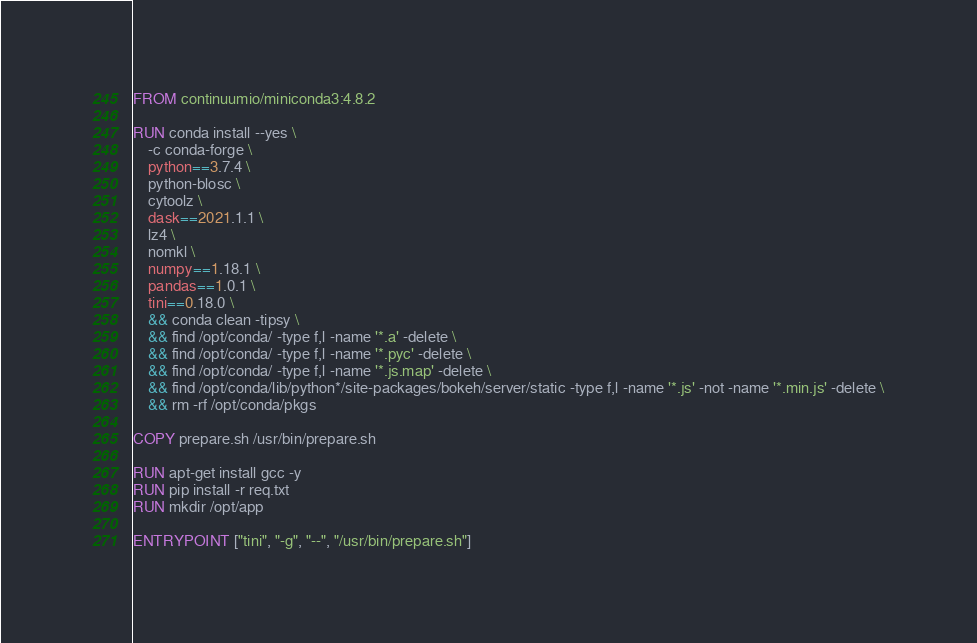Convert code to text. <code><loc_0><loc_0><loc_500><loc_500><_Dockerfile_>FROM continuumio/miniconda3:4.8.2

RUN conda install --yes \
    -c conda-forge \
    python==3.7.4 \
    python-blosc \
    cytoolz \
    dask==2021.1.1 \
    lz4 \
    nomkl \
    numpy==1.18.1 \
    pandas==1.0.1 \
    tini==0.18.0 \
    && conda clean -tipsy \
    && find /opt/conda/ -type f,l -name '*.a' -delete \
    && find /opt/conda/ -type f,l -name '*.pyc' -delete \
    && find /opt/conda/ -type f,l -name '*.js.map' -delete \
    && find /opt/conda/lib/python*/site-packages/bokeh/server/static -type f,l -name '*.js' -not -name '*.min.js' -delete \
    && rm -rf /opt/conda/pkgs

COPY prepare.sh /usr/bin/prepare.sh

RUN apt-get install gcc -y
RUN pip install -r req.txt
RUN mkdir /opt/app

ENTRYPOINT ["tini", "-g", "--", "/usr/bin/prepare.sh"]
</code> 